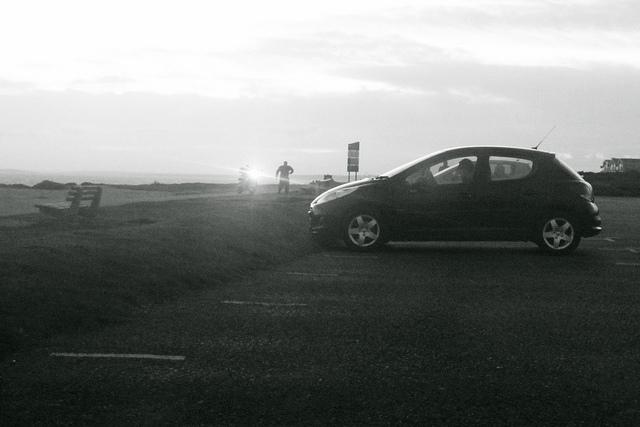What kind of car is this?
Quick response, please. Subaru. What kind of vehicle is shown?
Answer briefly. Car. How many people in the picture?
Concise answer only. 3. What vehicle is this?
Write a very short answer. Car. Do you see a reflection?
Write a very short answer. No. Is the light that is shining on the object above or below the object?
Answer briefly. Above. Was this picture taken in a dry or wet area?
Write a very short answer. Dry. Is this a sunrise or sunset?
Concise answer only. Sunrise. How many vehicles are blue?
Give a very brief answer. 0. Is the car door to open?
Concise answer only. No. How many cars are in the picture?
Short answer required. 1. Can this vehicle be driven on sand?
Answer briefly. No. Is that a car?
Concise answer only. Yes. What color is the car?
Quick response, please. Black. 